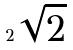Convert formula to latex. <formula><loc_0><loc_0><loc_500><loc_500>2 \sqrt { 2 }</formula> 